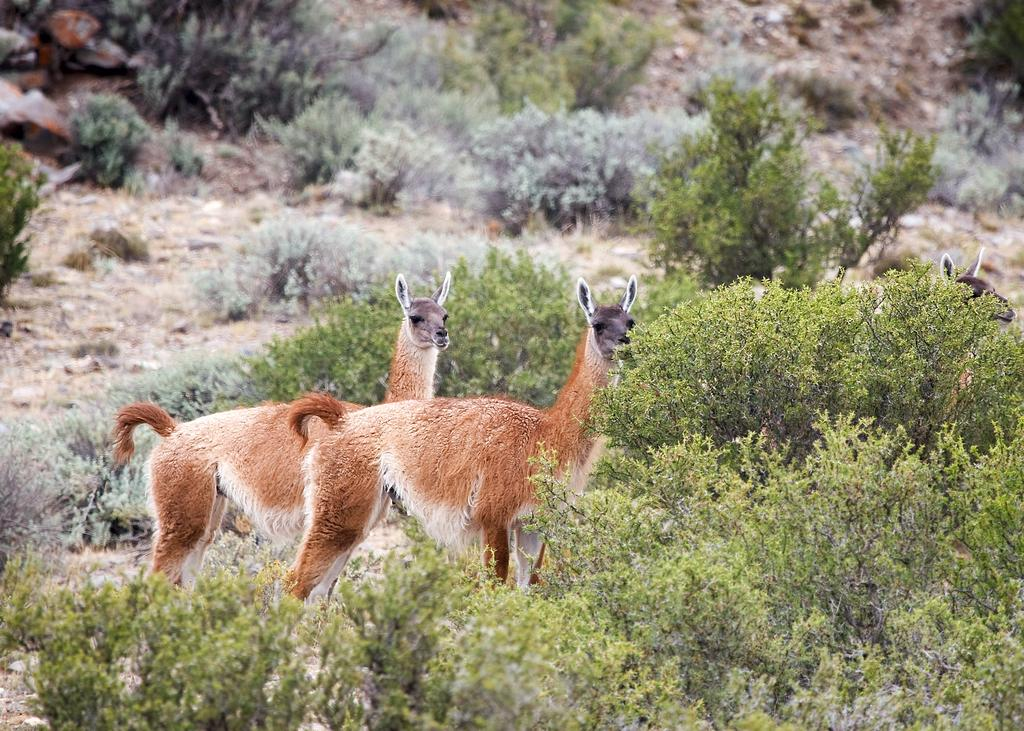What animals are present in the image? There are two guanacos in the image. What type of vegetation can be seen in the image? There are small bushes and trees in the image. Can you describe the position of one of the guanacos? The face of one guanaco is visible behind a tree. What type of metal can be seen near the seashore in the image? There is no seashore or metal present in the image; it features two guanacos, small bushes, trees, and one guanaco's face visible behind a tree. 